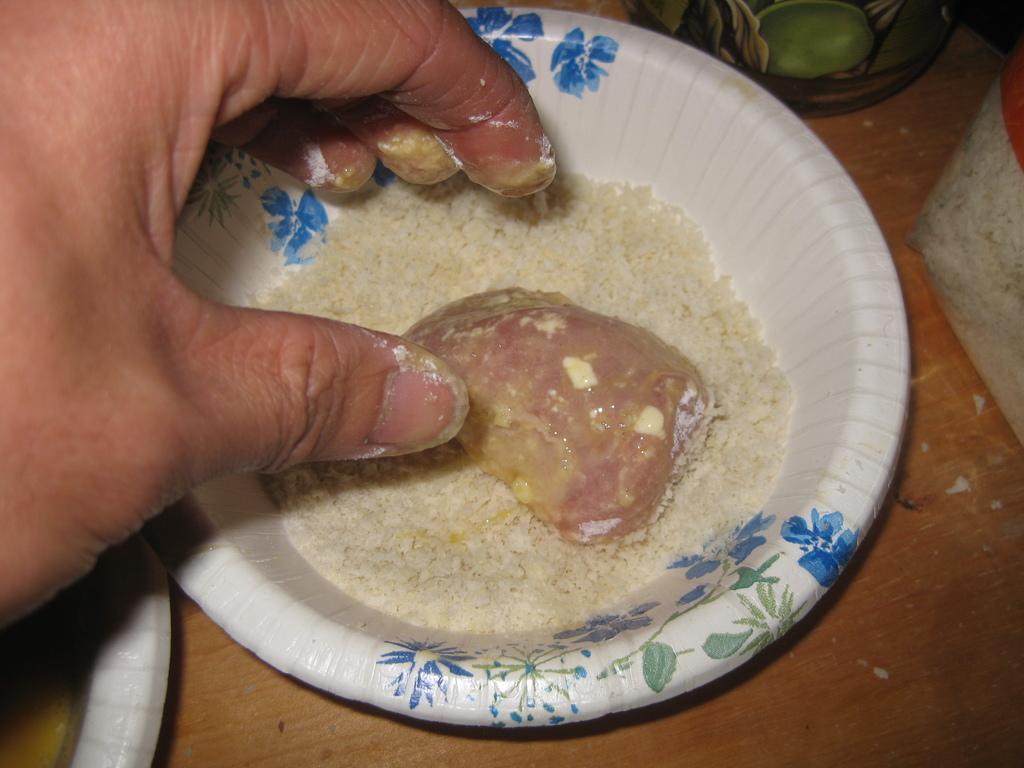Can you describe this image briefly? In this image we can see a food item in a bowl placed on the wooden surface and we can also see a human hand. 